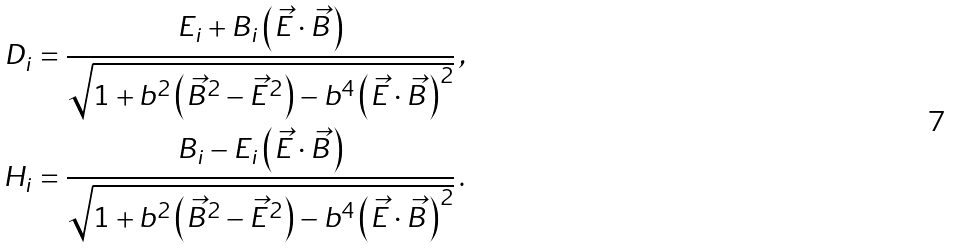Convert formula to latex. <formula><loc_0><loc_0><loc_500><loc_500>D _ { i } & = \frac { E _ { i } + B _ { i } \left ( \vec { E } \cdot \vec { B } \right ) } { \sqrt { 1 + b ^ { 2 } \left ( \vec { B } ^ { 2 } - \vec { E } ^ { 2 } \right ) - b ^ { 4 } \left ( \vec { E } \cdot \vec { B } \right ) ^ { 2 } } } \, , \\ H _ { i } & = \frac { B _ { i } - E _ { i } \left ( \vec { E } \cdot \vec { B } \right ) } { \sqrt { 1 + b ^ { 2 } \left ( \vec { B } ^ { 2 } - \vec { E } ^ { 2 } \right ) - b ^ { 4 } \left ( \vec { E } \cdot \vec { B } \right ) ^ { 2 } } } \, .</formula> 